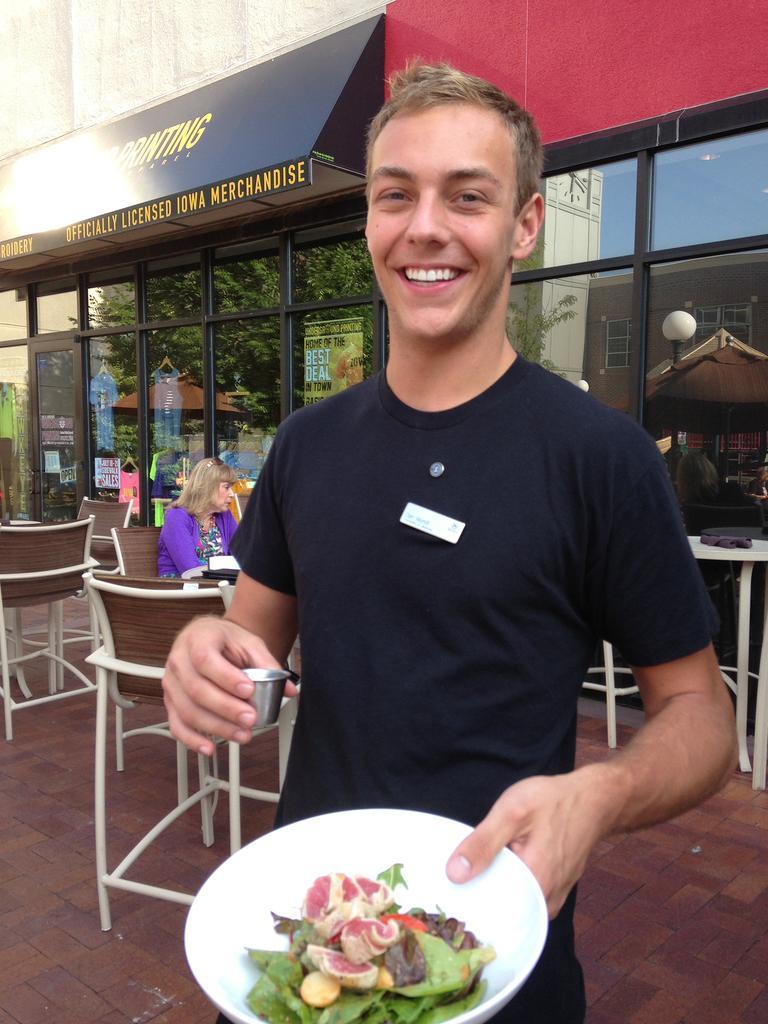Could you give a brief overview of what you see in this image? On the background we can see a store. On the glasses we can see reflection of building, trees. We can see one woman is sitting on chair near to the store. Here we can see one man wearing black colour shirt and he is holding a smile on his face. he is holding one small tiny glass in his hand and On the other hand we can see a plate in which there is a salad. 